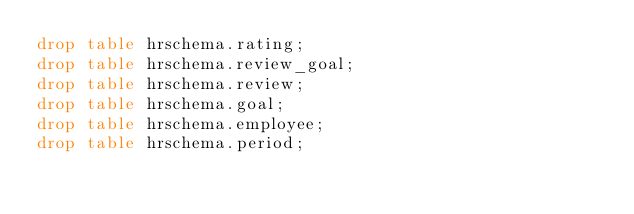Convert code to text. <code><loc_0><loc_0><loc_500><loc_500><_SQL_>drop table hrschema.rating;
drop table hrschema.review_goal;
drop table hrschema.review;
drop table hrschema.goal;
drop table hrschema.employee;
drop table hrschema.period;
</code> 